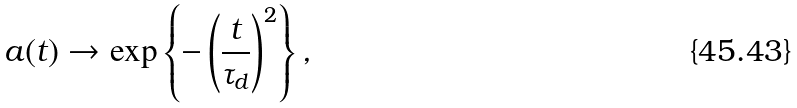Convert formula to latex. <formula><loc_0><loc_0><loc_500><loc_500>a ( t ) \rightarrow \exp \left \{ - \left ( \frac { t } { \tau _ { d } } \right ) ^ { 2 } \right \} ,</formula> 